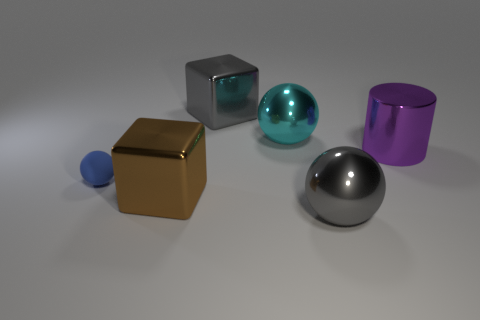Is there any other thing that has the same material as the tiny sphere?
Offer a very short reply. No. Is there anything else that is the same size as the blue thing?
Ensure brevity in your answer.  No. There is a cylinder that is the same size as the cyan metal object; what color is it?
Provide a short and direct response. Purple. Is the number of purple shiny things left of the small rubber thing less than the number of small spheres to the right of the purple cylinder?
Your answer should be compact. No. Is the size of the gray thing that is in front of the purple metal object the same as the brown shiny thing?
Give a very brief answer. Yes. What shape is the big gray shiny thing on the right side of the large cyan ball?
Keep it short and to the point. Sphere. Are there more tiny cyan objects than brown blocks?
Provide a succinct answer. No. Is the color of the large ball behind the cylinder the same as the tiny sphere?
Provide a short and direct response. No. How many objects are either big metal balls that are behind the brown cube or metallic balls that are behind the blue matte thing?
Provide a short and direct response. 1. How many shiny things are both behind the blue rubber ball and to the right of the large cyan metal sphere?
Give a very brief answer. 1. 